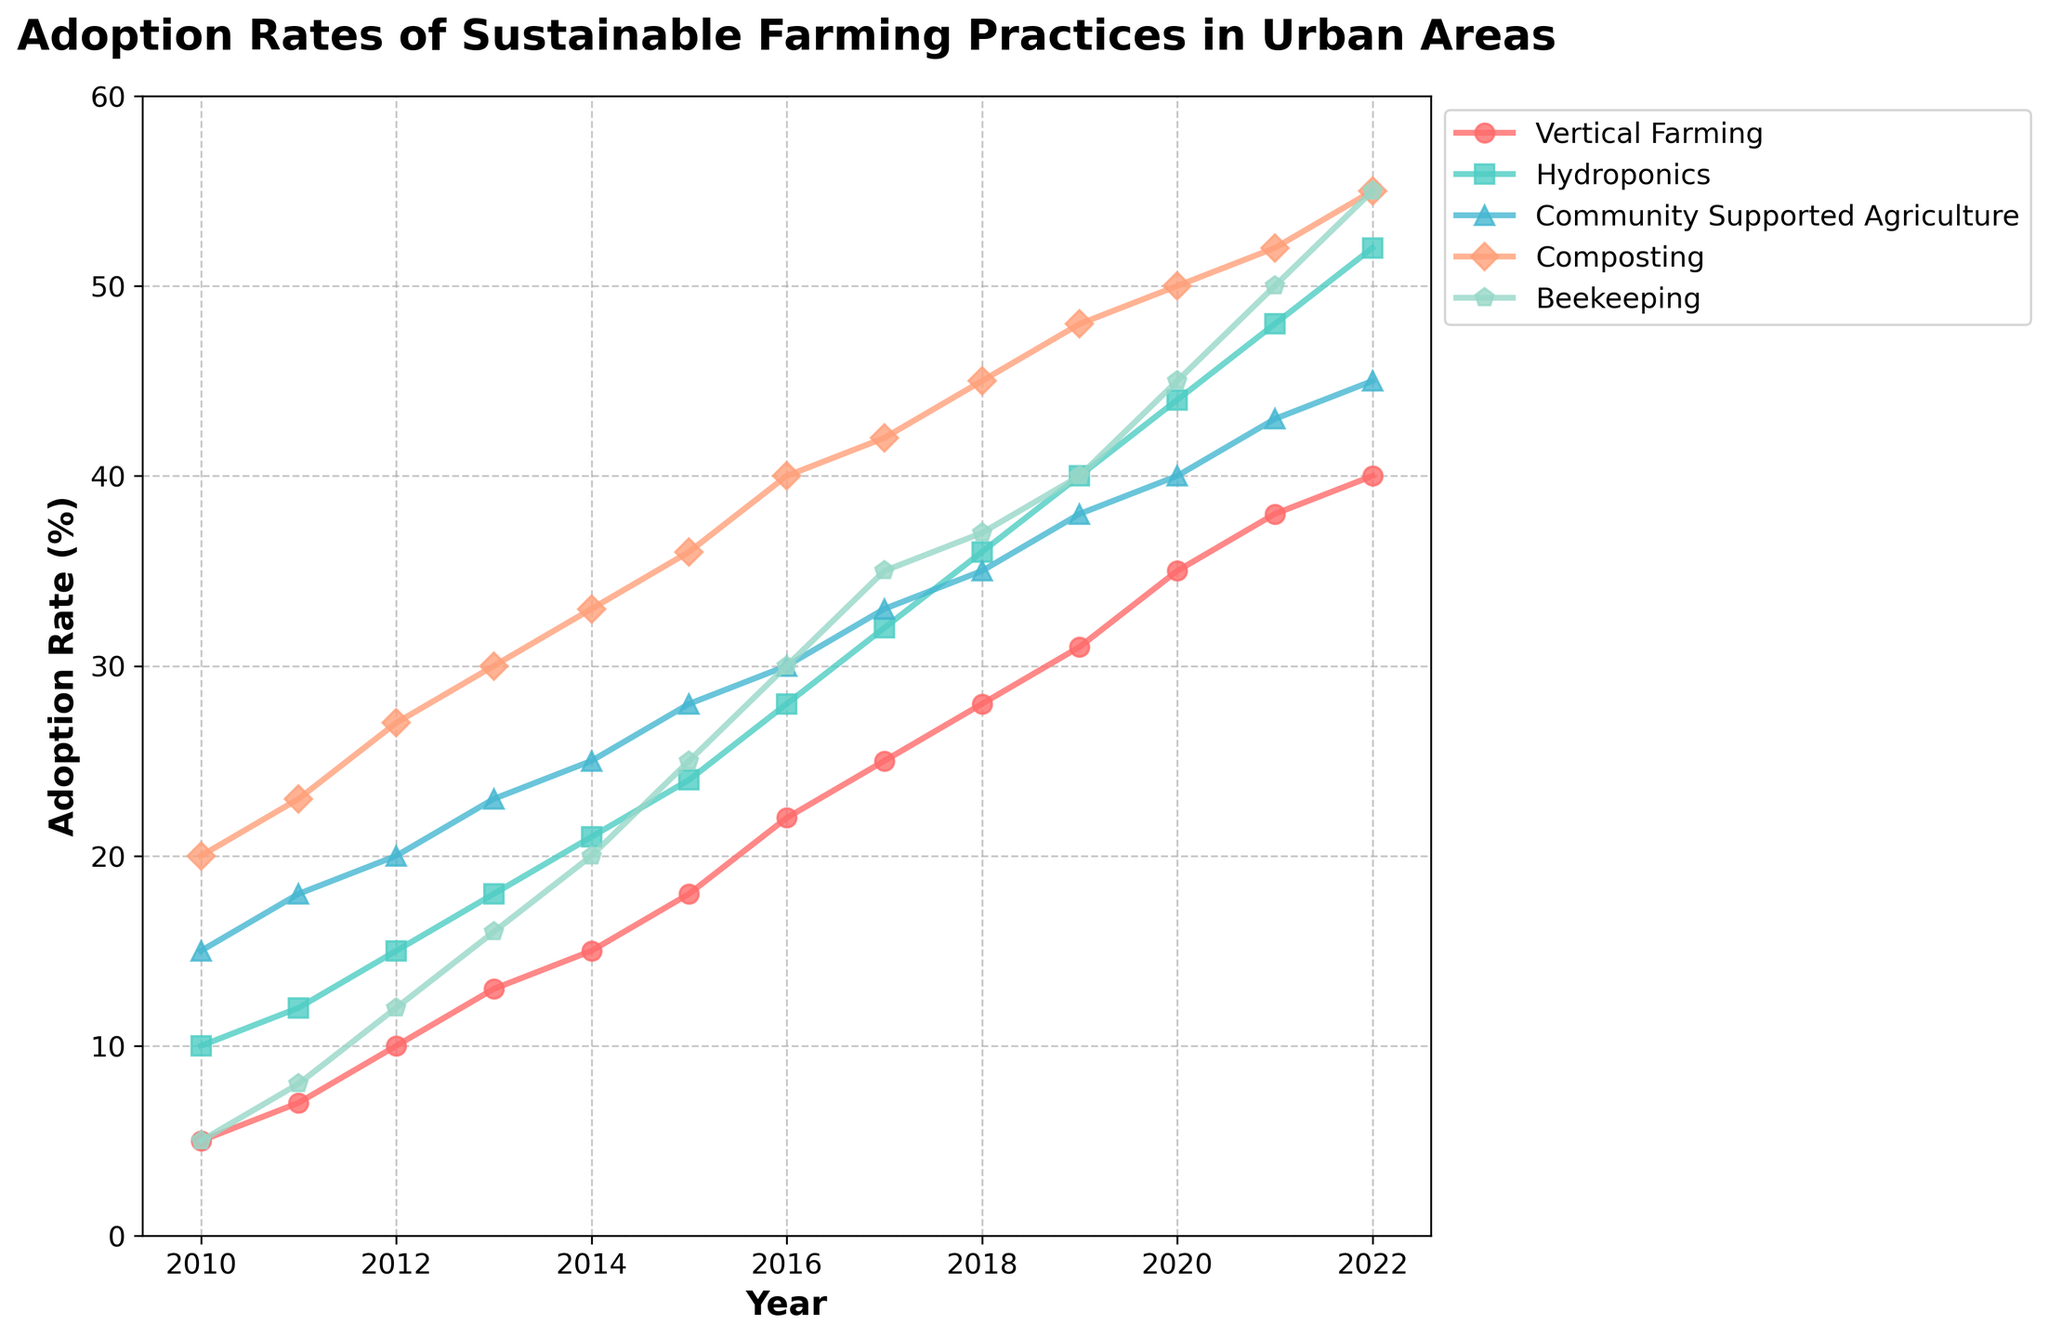what is the title of the plot? The title can be found at the top of the plot, usually in bold and larger font compared to axis labels. The title is "Adoption Rates of Sustainable Farming Practices in Urban Areas"
Answer: Adoption Rates of Sustainable Farming Practices in Urban Areas when did hydroponics see its biggest increase from the previous year? Compare the adoption rates of Hydroponics for each consecutive year and find the year with the largest increase. The biggest increase was from 2019 (40%) to 2020 (44%), which is an increase of 4%.
Answer: 2020 how many sustainable farming practices are tracked in the plot? Count the different line plots in the figure, each representing a different practice. There are five practices: Vertical Farming, Hydroponics, Community Supported Agriculture, Composting, and Beekeeping.
Answer: 5 which practice had the highest adoption rate in 2022? Look at the adoption rates for each practice in 2022 and find the highest value. Composting had the highest adoption rate in 2022 with 55%.
Answer: Composting compare the adoption rates of vertical farming and hydroponics in 2015. which one was higher? Locate the adoption rates of Vertical Farming and Hydroponics in the year 2015 and compare them. Vertical Farming was at 18%, while Hydroponics was at 24%. Hydroponics had a higher adoption rate.
Answer: Hydroponics what's the average adoption rate of beekeeping from 2010 to 2015? Sum the adoption rates of Beekeeping from 2010 to 2015: (5 + 8 + 12 + 16 + 20 + 25) = 86. Then divide by the number of years, which is 6: 86/6 = 14.33
Answer: 14.33% did community supported agriculture ever have a higher adoption rate than composting over the period? Compare the yearly adoption rates of Community Supported Agriculture and Composting. Community Supported Agriculture never surpassed the adoption rate of Composting during the given timeframe.
Answer: No what year had the highest overall adoption rate across all practices? Sum the adoption rates for all practices each year and identify the year with the highest sum. In 2022, the total adoption rate is (40 + 52 + 45 + 55 + 55) = 247, the highest overall.
Answer: 2022 which practice showed the most steady increase over time without any decreases? Examine the trends for each practice to identify the one that continuously increased every year without any drops. Vertical Farming showed a steady increase over the years without any decreases.
Answer: Vertical Farming in which year did vertical farming surpass an adoption rate of 20%? Identify the year when Vertical Farming first exceeded 20%. Vertical Farming surpassed 20% in 2016 with an adoption rate of 22%.
Answer: 2016 